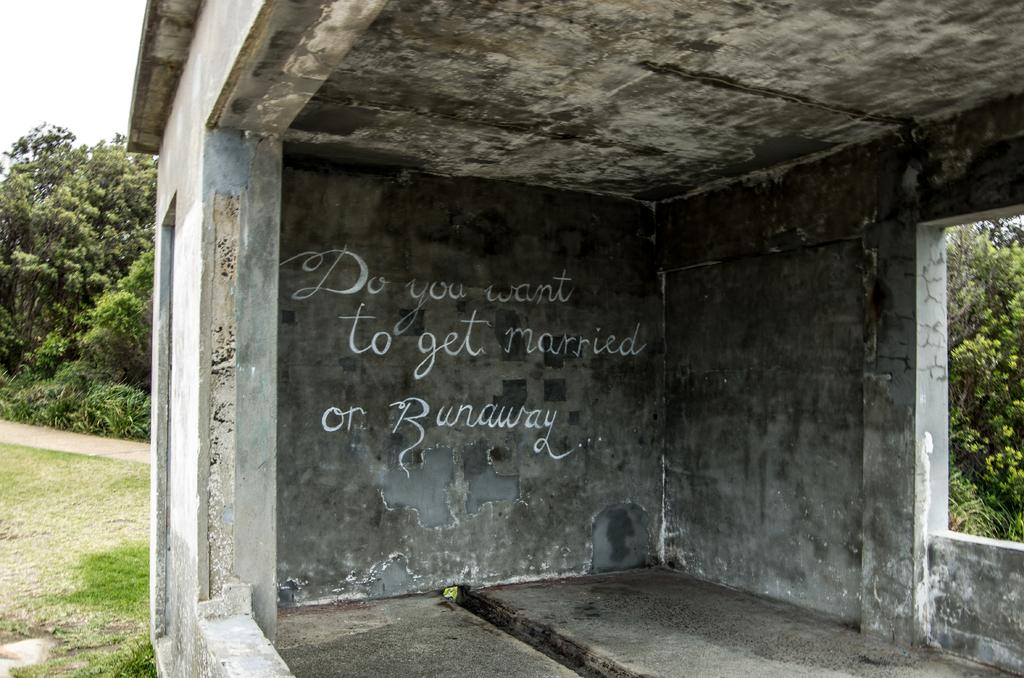What type of structure is present in the image? There is a building in the image. What can be seen on the wall of the building? There are words written on the wall of the building. What type of vegetation is visible in the background of the image? There are plants, grass, and trees in the background of the image. What part of the natural environment is visible in the image? The sky is visible in the background of the image. What type of punishment is being administered to the building in the image? There is no punishment being administered to the building in the image; it is a static structure. 